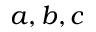<formula> <loc_0><loc_0><loc_500><loc_500>a , b , c</formula> 